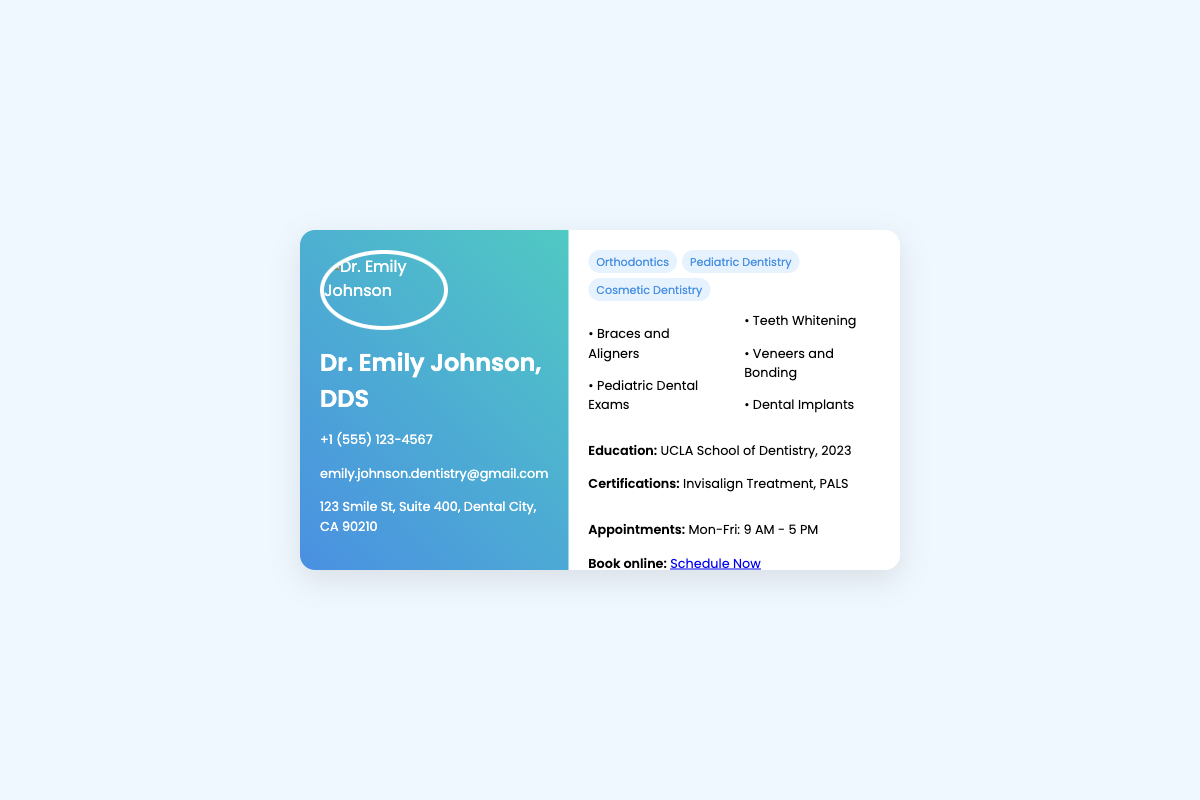what is the name on the business card? The name displayed prominently on the business card is Dr. Emily Johnson, DDS.
Answer: Dr. Emily Johnson, DDS what are the specialization areas listed? The business card lists three specialization areas: Orthodontics, Pediatric Dentistry, and Cosmetic Dentistry.
Answer: Orthodontics, Pediatric Dentistry, Cosmetic Dentistry what is the contact phone number? The contact phone number provided on the card is +1 (555) 123-4567.
Answer: +1 (555) 123-4567 what year did Dr. Emily Johnson graduate? The graduation year mentioned on the card is 2023.
Answer: 2023 which professional organizations are mentioned on the card? The card displays logos for several professional organizations, specifically the American Dental Association, California Dental Association, and Academy of General Dentistry.
Answer: American Dental Association, California Dental Association, Academy of General Dentistry what services does Dr. Emily Johnson offer? The key services provided include Braces and Aligners, Pediatric Dental Exams, Teeth Whitening, Veneers and Bonding, and Dental Implants.
Answer: Braces and Aligners, Pediatric Dental Exams, Teeth Whitening, Veneers and Bonding, Dental Implants what are the available appointment booking hours? The business card states that appointments are available from Monday to Friday, from 9 AM to 5 PM.
Answer: Mon-Fri: 9 AM - 5 PM what is the online booking link? The card provides a link for booking appointments, which is https://example.com/book-appointment.
Answer: https://example.com/book-appointment what is Dr. Emily Johnson's email address? The email address listed on the business card is emily.johnson.dentistry@gmail.com.
Answer: emily.johnson.dentistry@gmail.com 